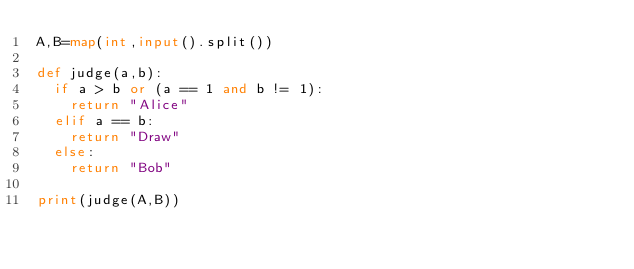Convert code to text. <code><loc_0><loc_0><loc_500><loc_500><_Python_>A,B=map(int,input().split())

def judge(a,b):
  if a > b or (a == 1 and b != 1):
    return "Alice"
  elif a == b:
    return "Draw"
  else:
    return "Bob"
  
print(judge(A,B))</code> 